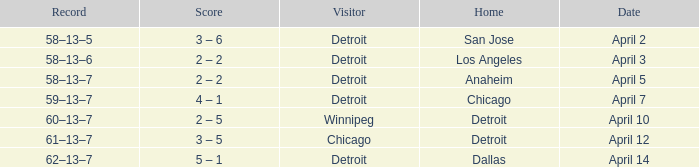What is the date of the game that had a visitor of Chicago? April 12. Parse the table in full. {'header': ['Record', 'Score', 'Visitor', 'Home', 'Date'], 'rows': [['58–13–5', '3 – 6', 'Detroit', 'San Jose', 'April 2'], ['58–13–6', '2 – 2', 'Detroit', 'Los Angeles', 'April 3'], ['58–13–7', '2 – 2', 'Detroit', 'Anaheim', 'April 5'], ['59–13–7', '4 – 1', 'Detroit', 'Chicago', 'April 7'], ['60–13–7', '2 – 5', 'Winnipeg', 'Detroit', 'April 10'], ['61–13–7', '3 – 5', 'Chicago', 'Detroit', 'April 12'], ['62–13–7', '5 – 1', 'Detroit', 'Dallas', 'April 14']]} 